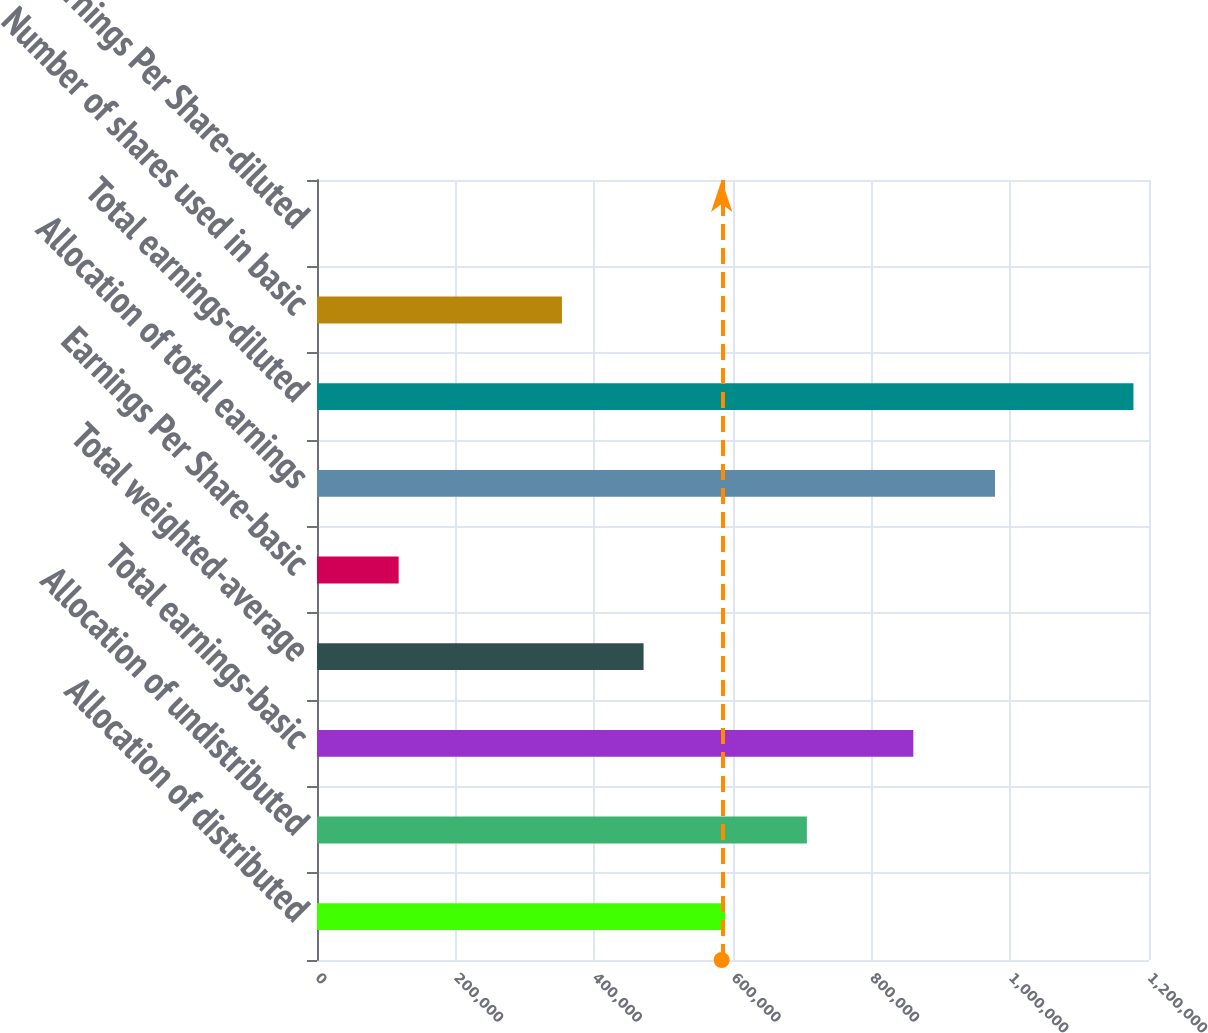Convert chart. <chart><loc_0><loc_0><loc_500><loc_500><bar_chart><fcel>Allocation of distributed<fcel>Allocation of undistributed<fcel>Total earnings-basic<fcel>Total weighted-average<fcel>Earnings Per Share-basic<fcel>Allocation of total earnings<fcel>Total earnings-diluted<fcel>Number of shares used in basic<fcel>Earnings Per Share-diluted<nl><fcel>588784<fcel>706539<fcel>860104<fcel>471028<fcel>117761<fcel>977860<fcel>1.17756e+06<fcel>353272<fcel>5.58<nl></chart> 